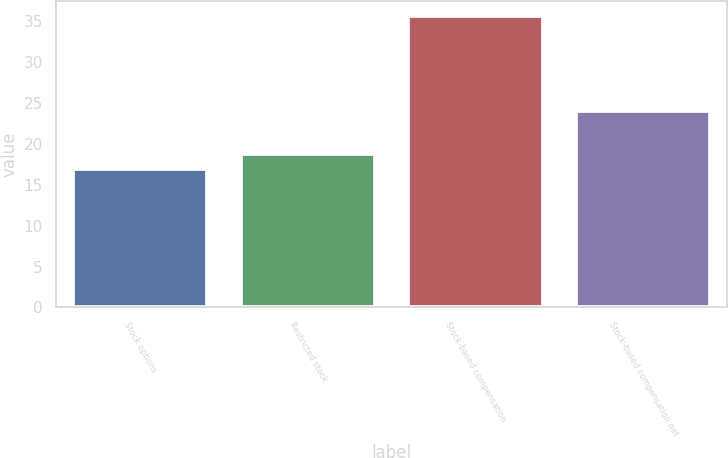<chart> <loc_0><loc_0><loc_500><loc_500><bar_chart><fcel>Stock options<fcel>Restricted stock<fcel>Stock-based compensation<fcel>Stock-based compensation net<nl><fcel>16.9<fcel>18.77<fcel>35.6<fcel>24<nl></chart> 